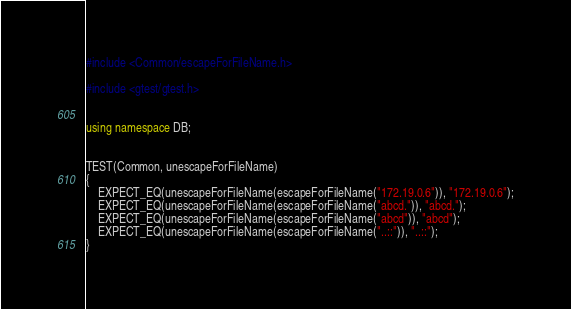<code> <loc_0><loc_0><loc_500><loc_500><_C++_>#include <Common/escapeForFileName.h>

#include <gtest/gtest.h>


using namespace DB;


TEST(Common, unescapeForFileName)
{
    EXPECT_EQ(unescapeForFileName(escapeForFileName("172.19.0.6")), "172.19.0.6");
    EXPECT_EQ(unescapeForFileName(escapeForFileName("abcd.")), "abcd.");
    EXPECT_EQ(unescapeForFileName(escapeForFileName("abcd")), "abcd");
    EXPECT_EQ(unescapeForFileName(escapeForFileName("..::")), "..::");
}
</code> 